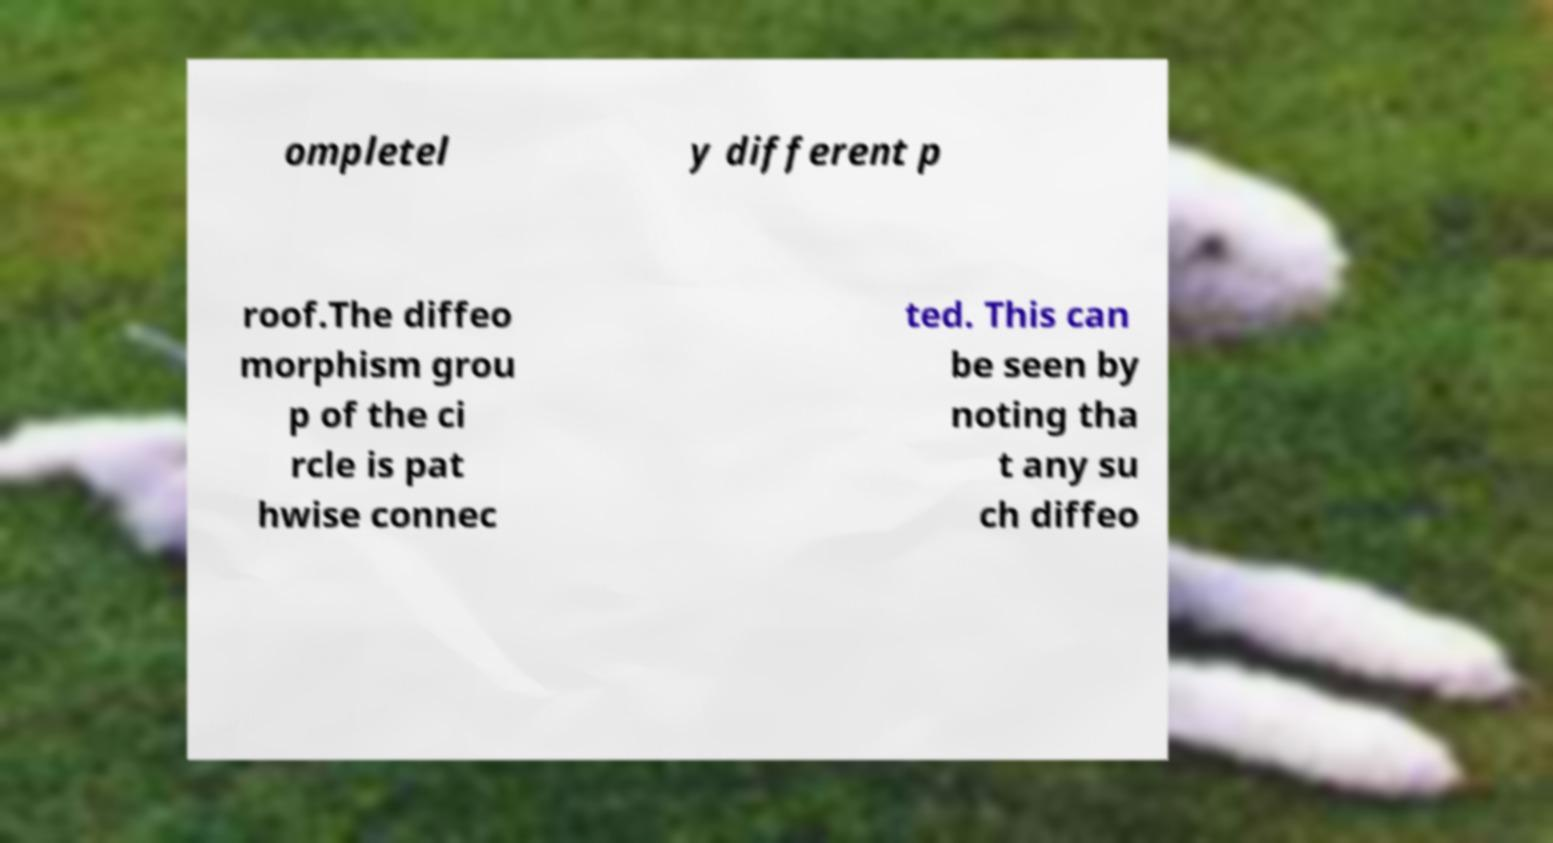Can you read and provide the text displayed in the image?This photo seems to have some interesting text. Can you extract and type it out for me? ompletel y different p roof.The diffeo morphism grou p of the ci rcle is pat hwise connec ted. This can be seen by noting tha t any su ch diffeo 